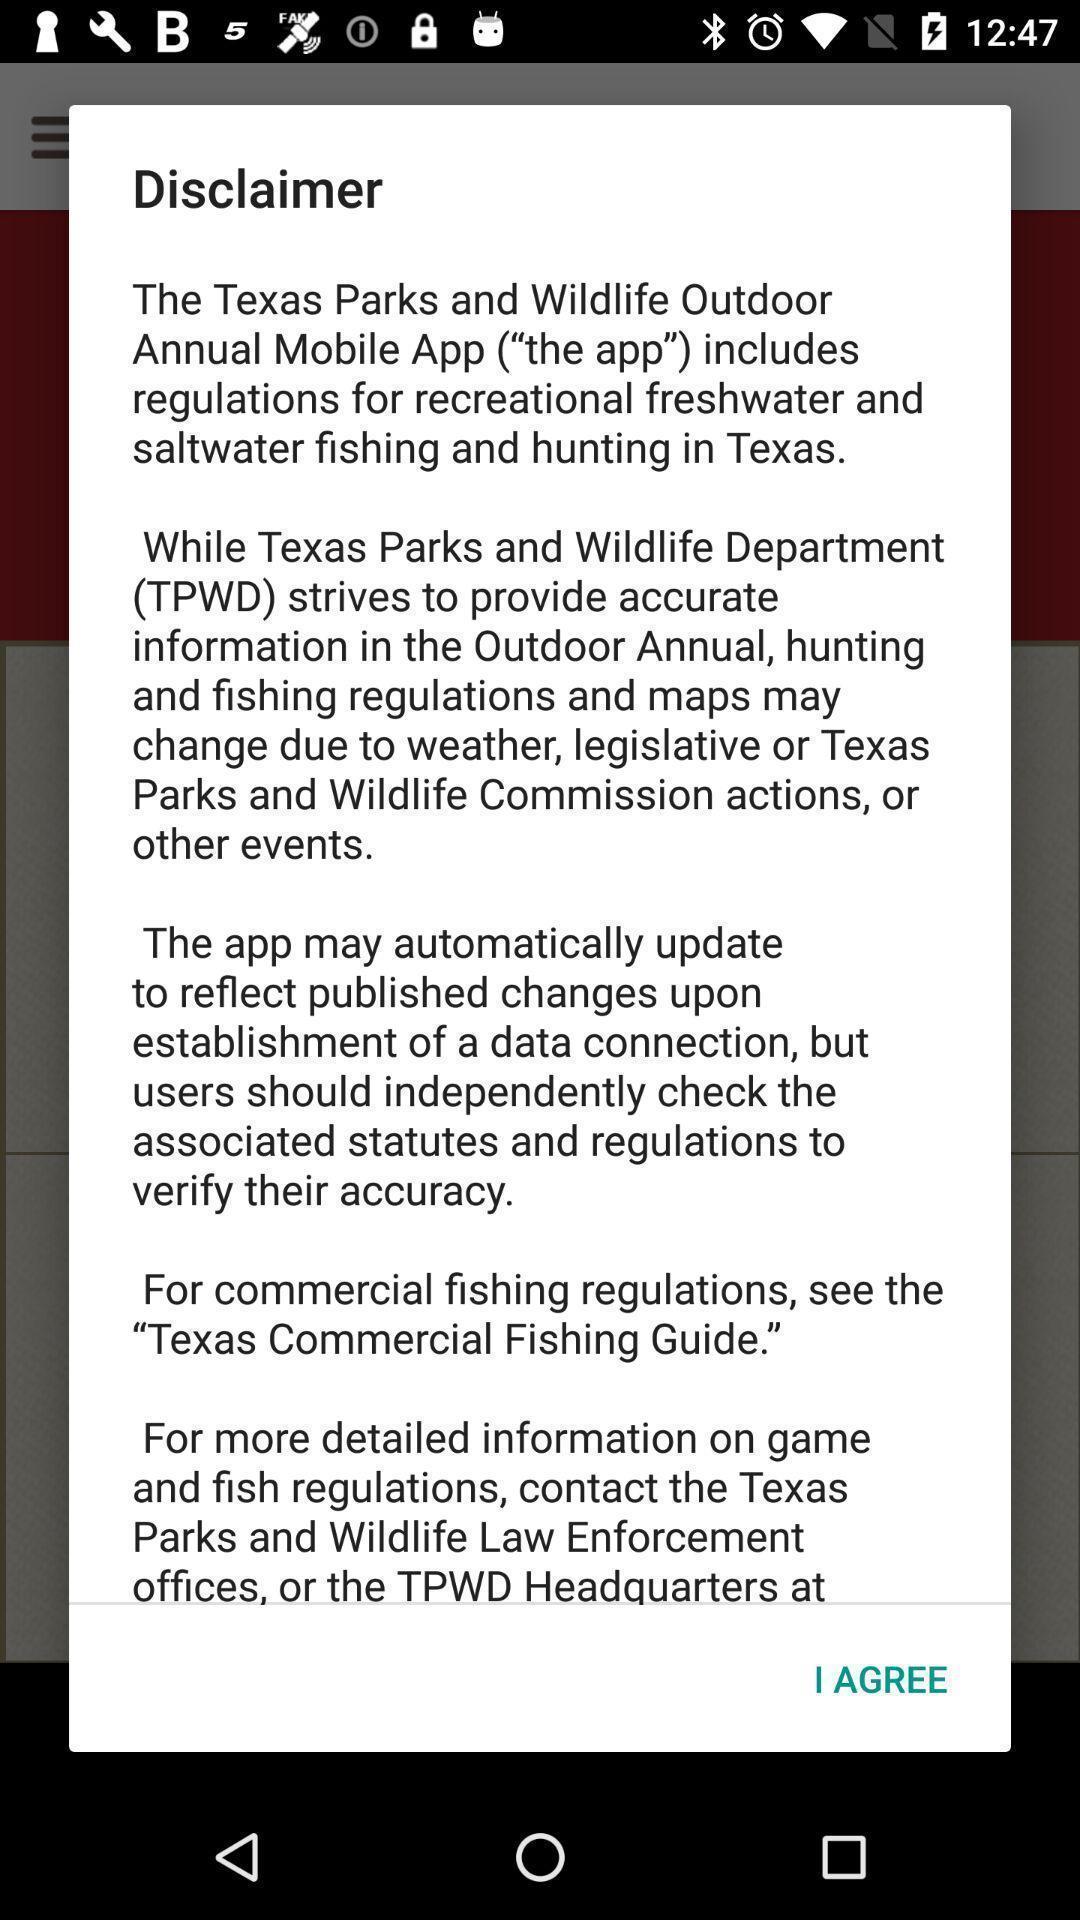Summarize the information in this screenshot. Pop-up shows disclaimer. 